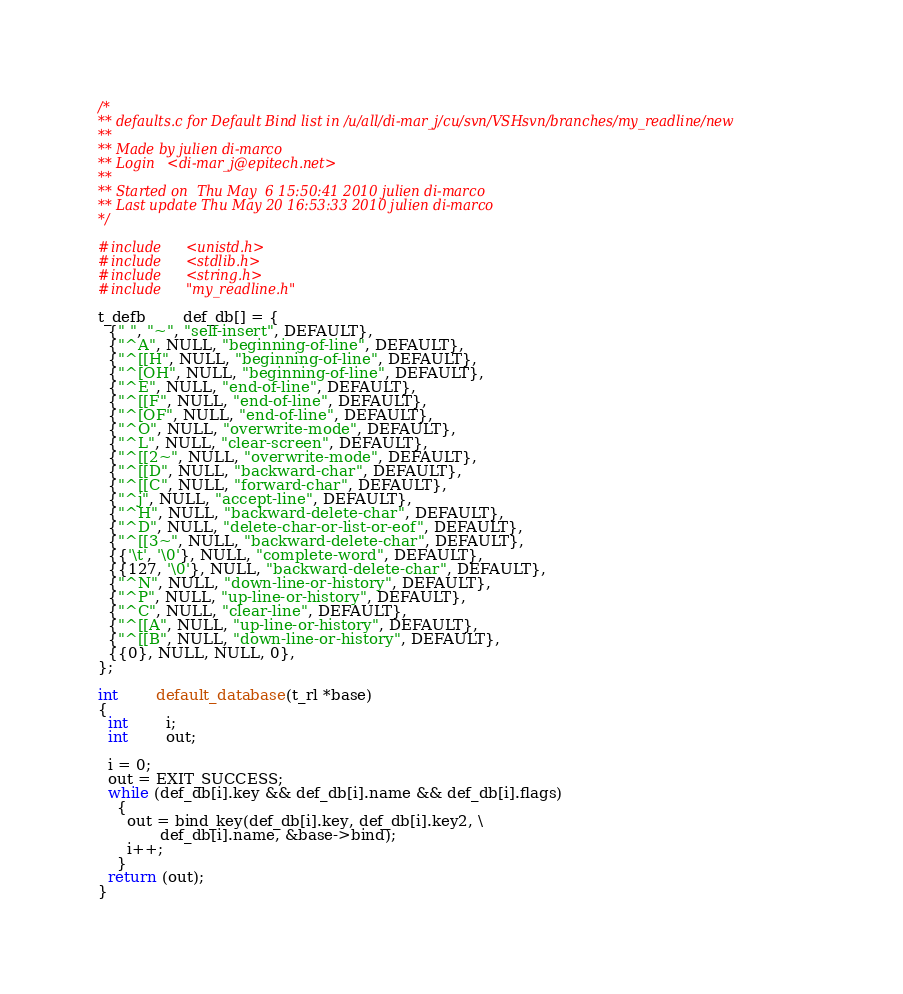Convert code to text. <code><loc_0><loc_0><loc_500><loc_500><_C_>/*
** defaults.c for Default Bind list in /u/all/di-mar_j/cu/svn/VSHsvn/branches/my_readline/new
** 
** Made by julien di-marco
** Login   <di-mar_j@epitech.net>
** 
** Started on  Thu May  6 15:50:41 2010 julien di-marco
** Last update Thu May 20 16:53:33 2010 julien di-marco
*/

#include	<unistd.h>
#include	<stdlib.h>
#include	<string.h>
#include	"my_readline.h"

t_defb		def_db[] = {
  {" ", "~", "self-insert", DEFAULT},
  {"^A", NULL, "beginning-of-line", DEFAULT},
  {"^[[H", NULL, "beginning-of-line", DEFAULT},
  {"^[OH", NULL, "beginning-of-line", DEFAULT},
  {"^E", NULL, "end-of-line", DEFAULT},
  {"^[[F", NULL, "end-of-line", DEFAULT},
  {"^[OF", NULL, "end-of-line", DEFAULT},
  {"^O", NULL, "overwrite-mode", DEFAULT},
  {"^L", NULL, "clear-screen", DEFAULT},
  {"^[[2~", NULL, "overwrite-mode", DEFAULT},
  {"^[[D", NULL, "backward-char", DEFAULT},
  {"^[[C", NULL, "forward-char", DEFAULT},
  {"^j", NULL, "accept-line", DEFAULT},
  {"^H", NULL, "backward-delete-char", DEFAULT},
  {"^D", NULL, "delete-char-or-list-or-eof", DEFAULT},
  {"^[[3~", NULL, "backward-delete-char", DEFAULT},
  {{'\t', '\0'}, NULL, "complete-word", DEFAULT},
  {{127, '\0'}, NULL, "backward-delete-char", DEFAULT},
  {"^N", NULL, "down-line-or-history", DEFAULT},
  {"^P", NULL, "up-line-or-history", DEFAULT},
  {"^C", NULL, "clear-line", DEFAULT},
  {"^[[A", NULL, "up-line-or-history", DEFAULT},
  {"^[[B", NULL, "down-line-or-history", DEFAULT},
  {{0}, NULL, NULL, 0},
};

int		default_database(t_rl *base)
{
  int		i;
  int		out;

  i = 0;
  out = EXIT_SUCCESS;
  while (def_db[i].key && def_db[i].name && def_db[i].flags)
    {
      out = bind_key(def_db[i].key, def_db[i].key2, \
		     def_db[i].name, &base->bind);
      i++;
    }
  return (out);
}
</code> 